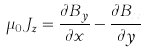<formula> <loc_0><loc_0><loc_500><loc_500>\mu _ { 0 } J _ { z } = \frac { \partial B _ { y } } { \partial x } - \frac { \partial B _ { x } } { \partial y }</formula> 